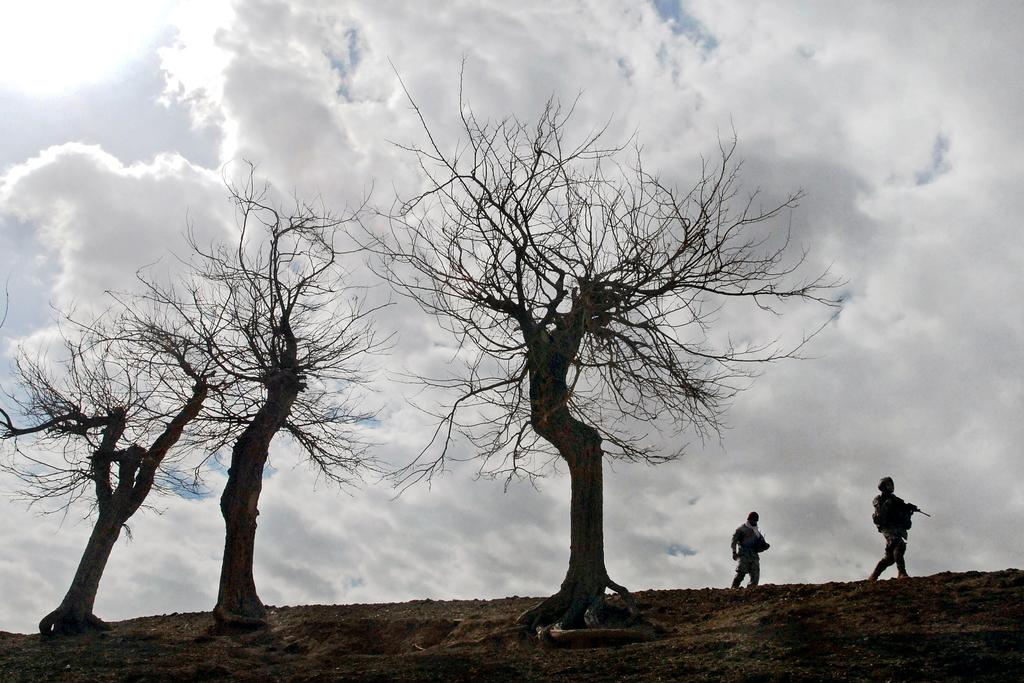What type of vegetation can be seen in the image? There are trees in the image. What are the people near the trees doing? The people walking near or among the trees suggest they might be taking a walk or enjoying the outdoors. What is the condition of the sky in the image? The sky is cloudy in the image. Can you see a plane flying in the sky in the image? There is no plane visible in the sky in the image. How many crows are perched on the trees in the image? There are no crows present in the image. 